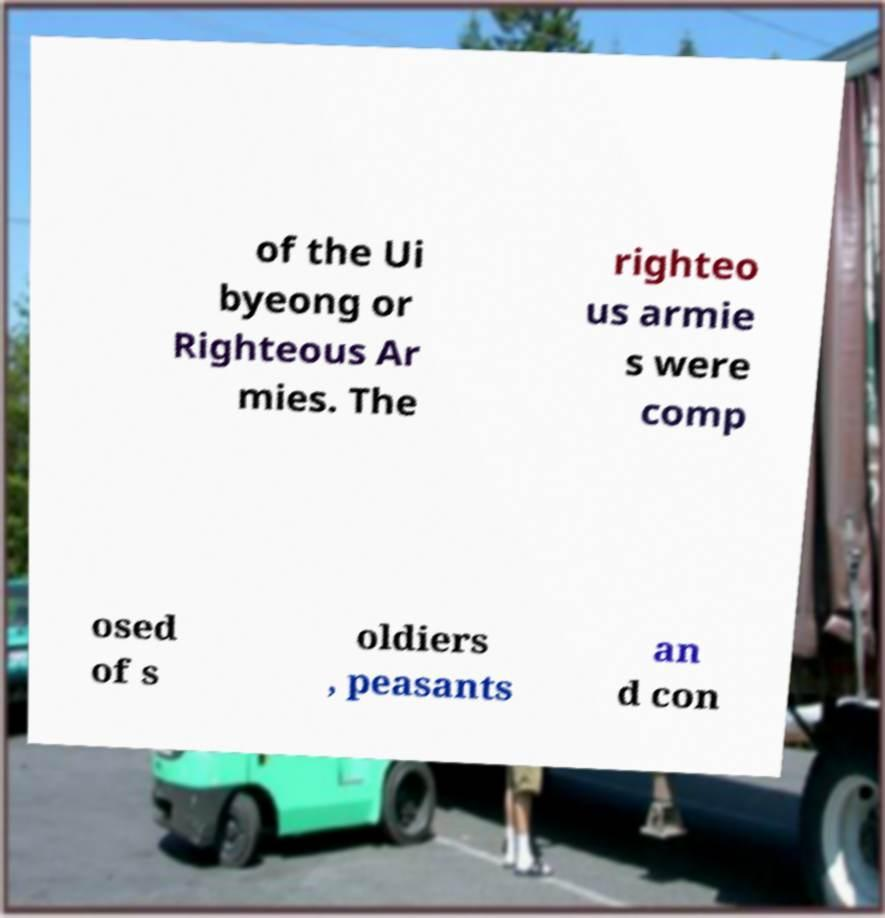Please read and relay the text visible in this image. What does it say? of the Ui byeong or Righteous Ar mies. The righteo us armie s were comp osed of s oldiers , peasants an d con 